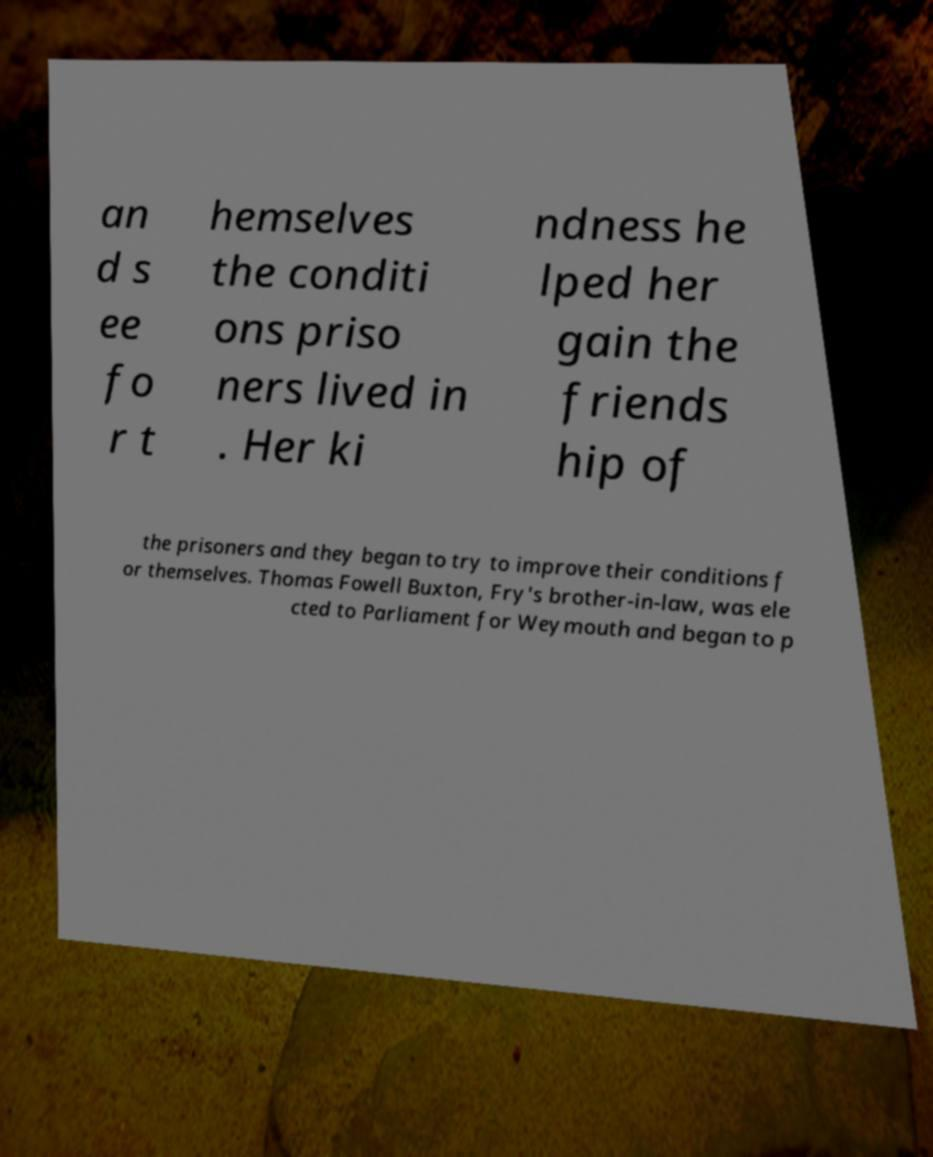Please read and relay the text visible in this image. What does it say? an d s ee fo r t hemselves the conditi ons priso ners lived in . Her ki ndness he lped her gain the friends hip of the prisoners and they began to try to improve their conditions f or themselves. Thomas Fowell Buxton, Fry's brother-in-law, was ele cted to Parliament for Weymouth and began to p 